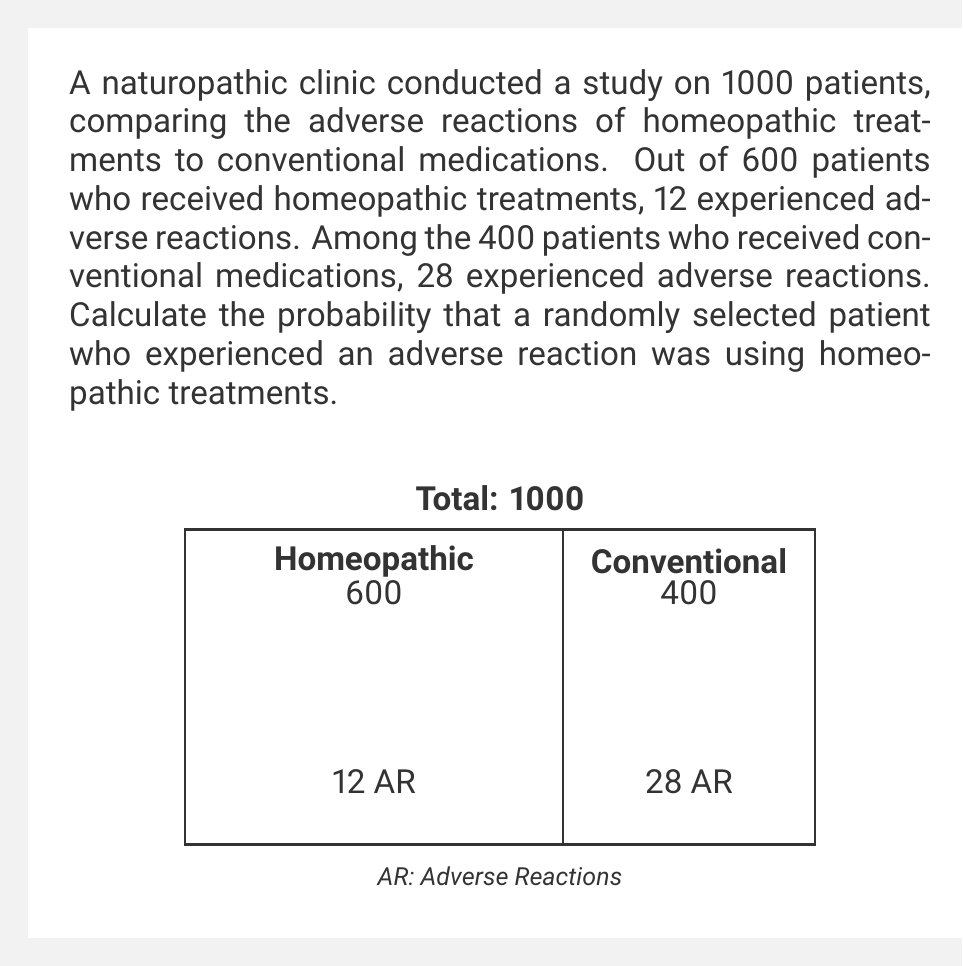What is the answer to this math problem? Let's approach this step-by-step using Bayes' theorem:

1) Let H be the event that a patient received homeopathic treatment, and A be the event that a patient experienced an adverse reaction.

2) We need to calculate P(H|A), the probability that a patient received homeopathic treatment given that they experienced an adverse reaction.

3) Bayes' theorem states:

   $$P(H|A) = \frac{P(A|H) \cdot P(H)}{P(A)}$$

4) Let's calculate each component:

   P(H) = 600/1000 = 0.6 (probability of receiving homeopathic treatment)
   P(A|H) = 12/600 = 0.02 (probability of adverse reaction given homeopathic treatment)
   P(A) = (12 + 28)/1000 = 0.04 (total probability of adverse reaction)

5) Substituting these values into Bayes' theorem:

   $$P(H|A) = \frac{0.02 \cdot 0.6}{0.04} = \frac{0.012}{0.04} = 0.3$$

6) Convert to a percentage:

   0.3 * 100 = 30%

Therefore, the probability that a randomly selected patient who experienced an adverse reaction was using homeopathic treatments is 30%.
Answer: 30% 